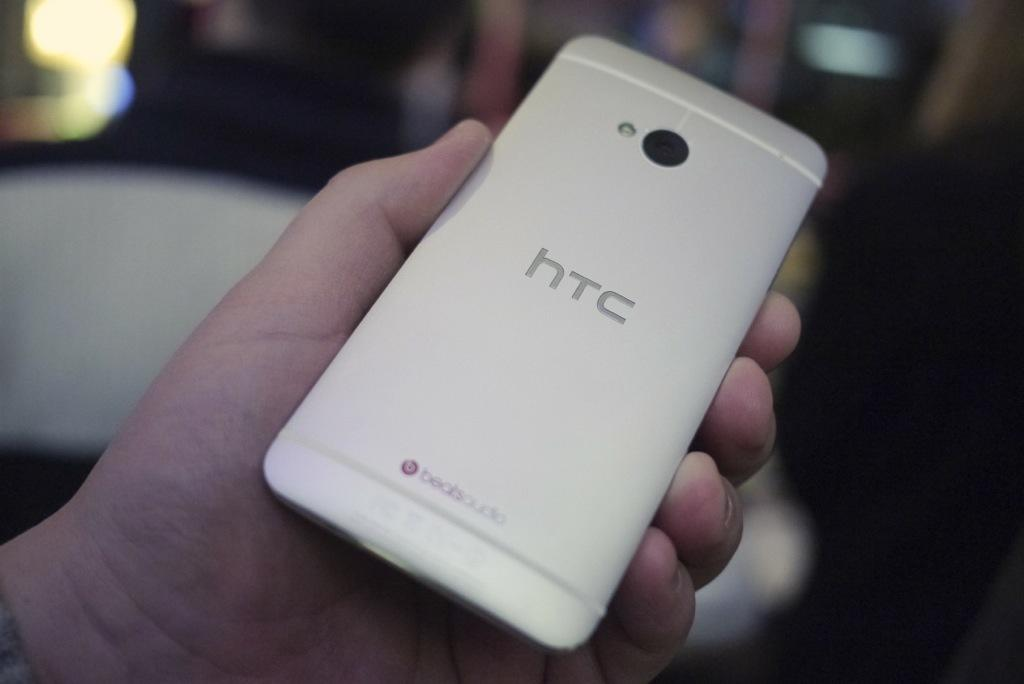<image>
Write a terse but informative summary of the picture. a person holding the back of an htc phone upward 